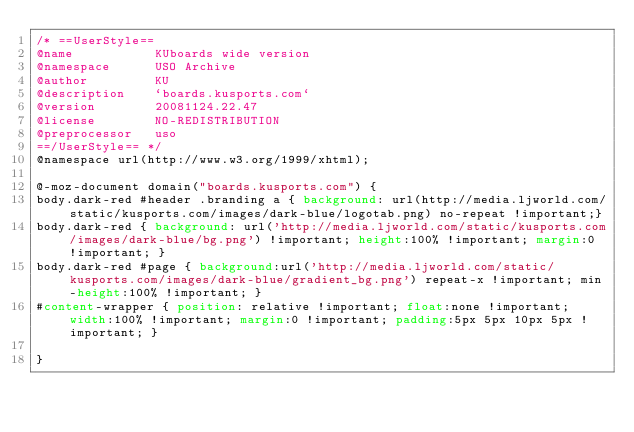Convert code to text. <code><loc_0><loc_0><loc_500><loc_500><_CSS_>/* ==UserStyle==
@name           KUboards wide version
@namespace      USO Archive
@author         KU
@description    `boards.kusports.com`
@version        20081124.22.47
@license        NO-REDISTRIBUTION
@preprocessor   uso
==/UserStyle== */
@namespace url(http://www.w3.org/1999/xhtml);

@-moz-document domain("boards.kusports.com") {
body.dark-red #header .branding a { background: url(http://media.ljworld.com/static/kusports.com/images/dark-blue/logotab.png) no-repeat !important;}
body.dark-red { background: url('http://media.ljworld.com/static/kusports.com/images/dark-blue/bg.png') !important; height:100% !important; margin:0 !important; }
body.dark-red #page { background:url('http://media.ljworld.com/static/kusports.com/images/dark-blue/gradient_bg.png') repeat-x !important; min-height:100% !important; }
#content-wrapper { position: relative !important; float:none !important; width:100% !important; margin:0 !important; padding:5px 5px 10px 5px !important; }   
    
}</code> 